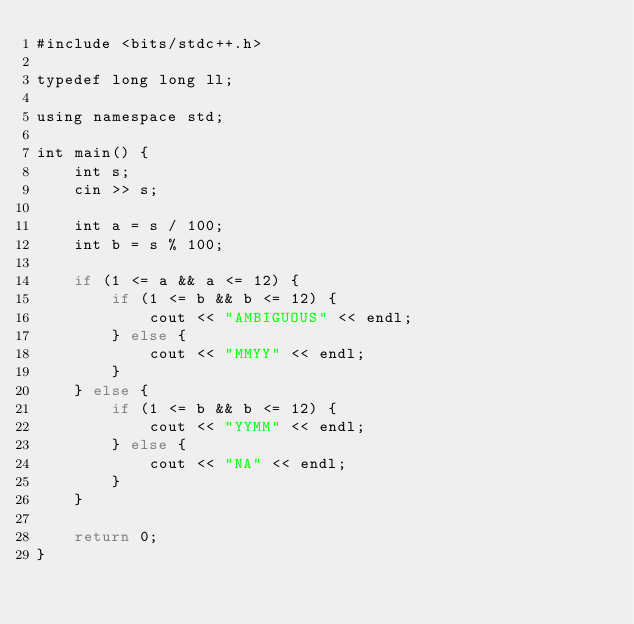Convert code to text. <code><loc_0><loc_0><loc_500><loc_500><_Rust_>#include <bits/stdc++.h>

typedef long long ll;

using namespace std;

int main() {
    int s;
    cin >> s;

    int a = s / 100;
    int b = s % 100;

    if (1 <= a && a <= 12) {
        if (1 <= b && b <= 12) {
            cout << "AMBIGUOUS" << endl;
        } else {
            cout << "MMYY" << endl;
        }
    } else {
        if (1 <= b && b <= 12) {
            cout << "YYMM" << endl;
        } else {
            cout << "NA" << endl;
        }
    }

    return 0;
}</code> 